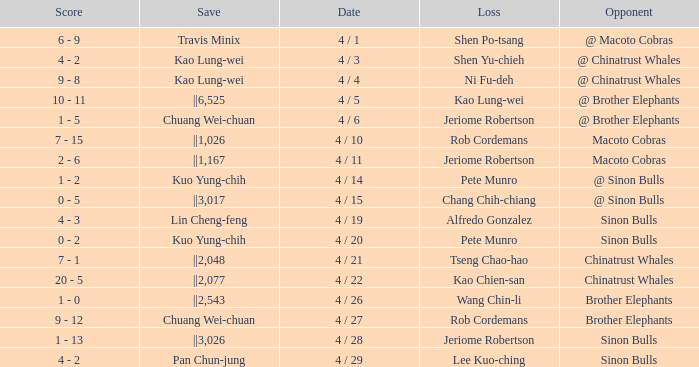Who earned the save in the game against the Sinon Bulls when Jeriome Robertson took the loss? ||3,026. 